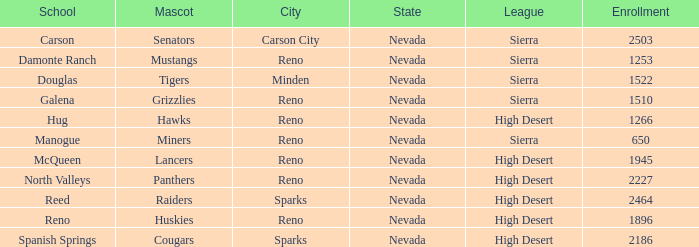Which school has the Raiders as their mascot? Reed. 